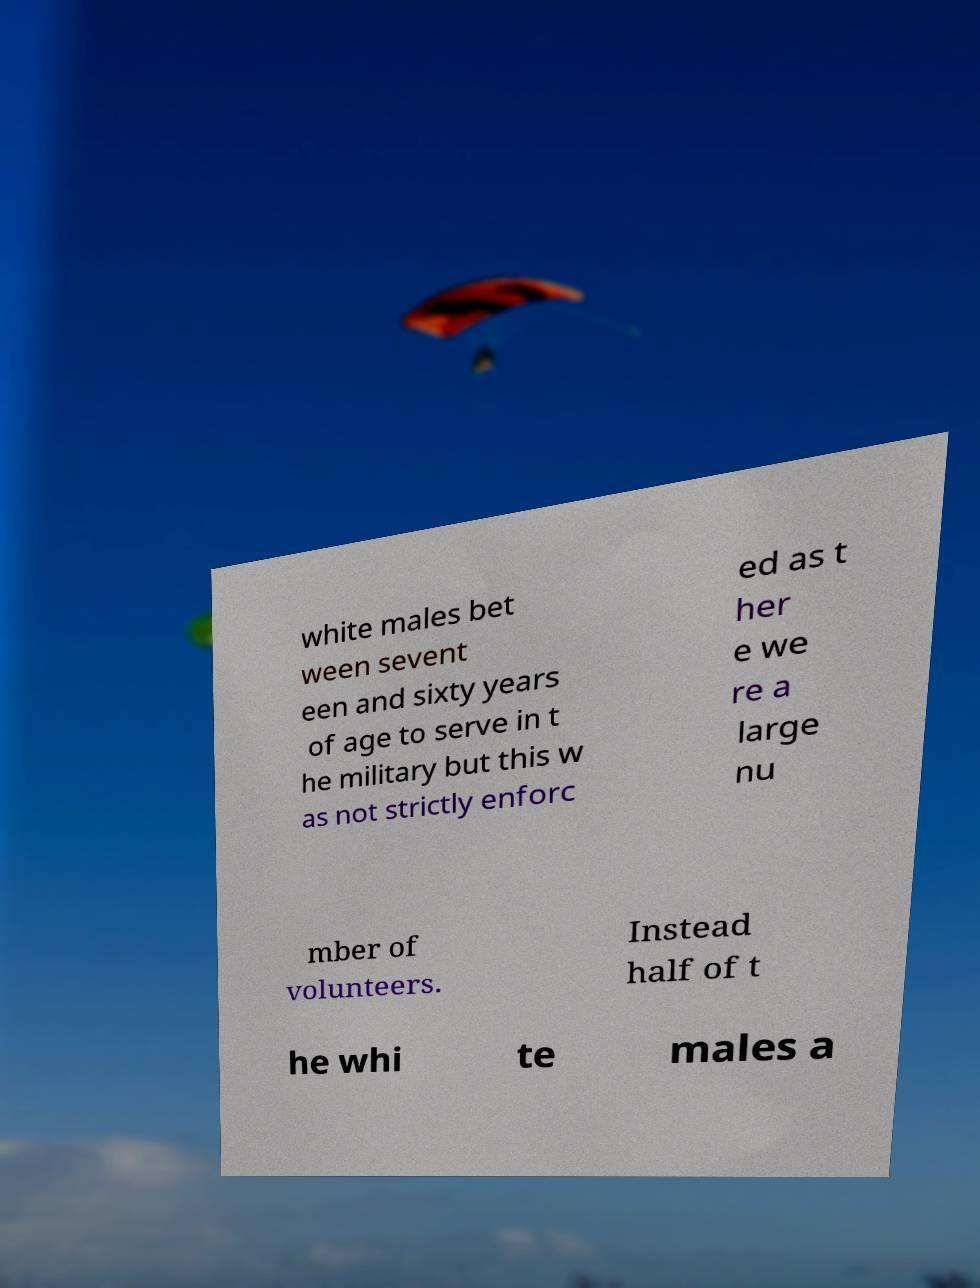Please identify and transcribe the text found in this image. white males bet ween sevent een and sixty years of age to serve in t he military but this w as not strictly enforc ed as t her e we re a large nu mber of volunteers. Instead half of t he whi te males a 